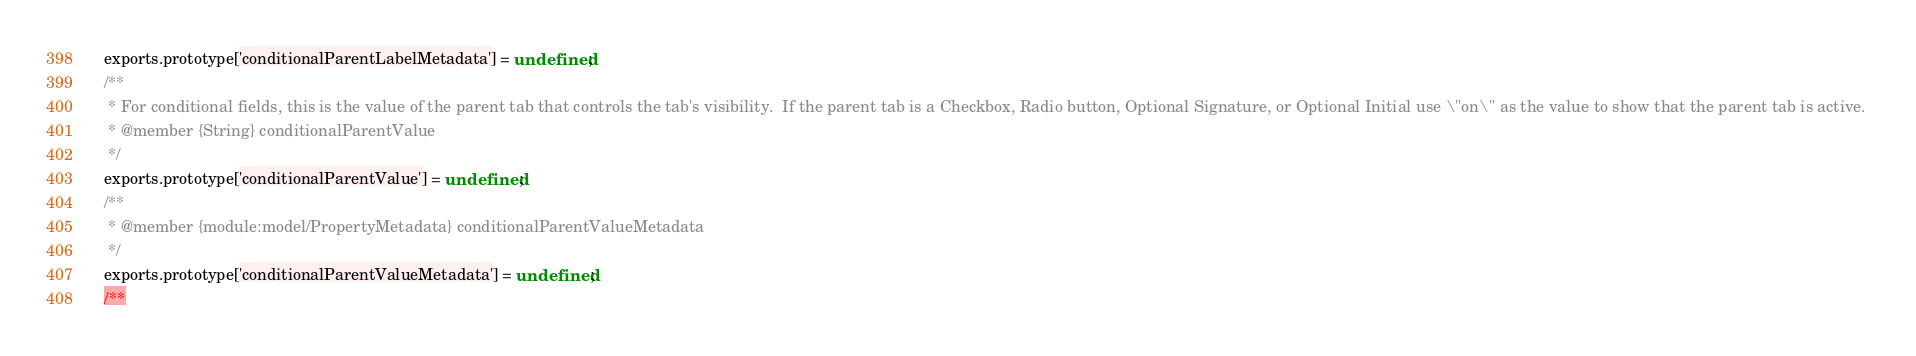<code> <loc_0><loc_0><loc_500><loc_500><_JavaScript_>  exports.prototype['conditionalParentLabelMetadata'] = undefined;
  /**
   * For conditional fields, this is the value of the parent tab that controls the tab's visibility.  If the parent tab is a Checkbox, Radio button, Optional Signature, or Optional Initial use \"on\" as the value to show that the parent tab is active. 
   * @member {String} conditionalParentValue
   */
  exports.prototype['conditionalParentValue'] = undefined;
  /**
   * @member {module:model/PropertyMetadata} conditionalParentValueMetadata
   */
  exports.prototype['conditionalParentValueMetadata'] = undefined;
  /**</code> 